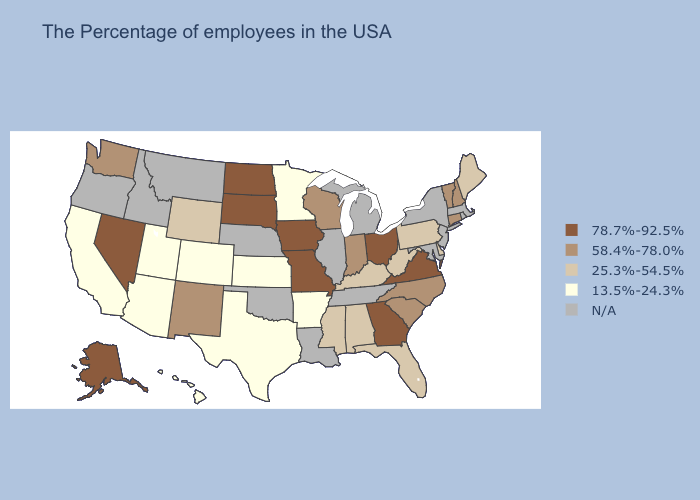Name the states that have a value in the range 58.4%-78.0%?
Answer briefly. New Hampshire, Vermont, Connecticut, North Carolina, South Carolina, Indiana, Wisconsin, New Mexico, Washington. Among the states that border Louisiana , does Mississippi have the lowest value?
Quick response, please. No. Does the first symbol in the legend represent the smallest category?
Quick response, please. No. Name the states that have a value in the range 13.5%-24.3%?
Concise answer only. Arkansas, Minnesota, Kansas, Texas, Colorado, Utah, Arizona, California, Hawaii. Which states have the lowest value in the USA?
Keep it brief. Arkansas, Minnesota, Kansas, Texas, Colorado, Utah, Arizona, California, Hawaii. What is the highest value in states that border Ohio?
Be succinct. 58.4%-78.0%. What is the lowest value in states that border New Hampshire?
Give a very brief answer. 25.3%-54.5%. What is the value of South Dakota?
Quick response, please. 78.7%-92.5%. What is the value of Delaware?
Keep it brief. 25.3%-54.5%. Name the states that have a value in the range 13.5%-24.3%?
Give a very brief answer. Arkansas, Minnesota, Kansas, Texas, Colorado, Utah, Arizona, California, Hawaii. What is the value of California?
Quick response, please. 13.5%-24.3%. What is the value of Kansas?
Give a very brief answer. 13.5%-24.3%. Name the states that have a value in the range 58.4%-78.0%?
Quick response, please. New Hampshire, Vermont, Connecticut, North Carolina, South Carolina, Indiana, Wisconsin, New Mexico, Washington. 